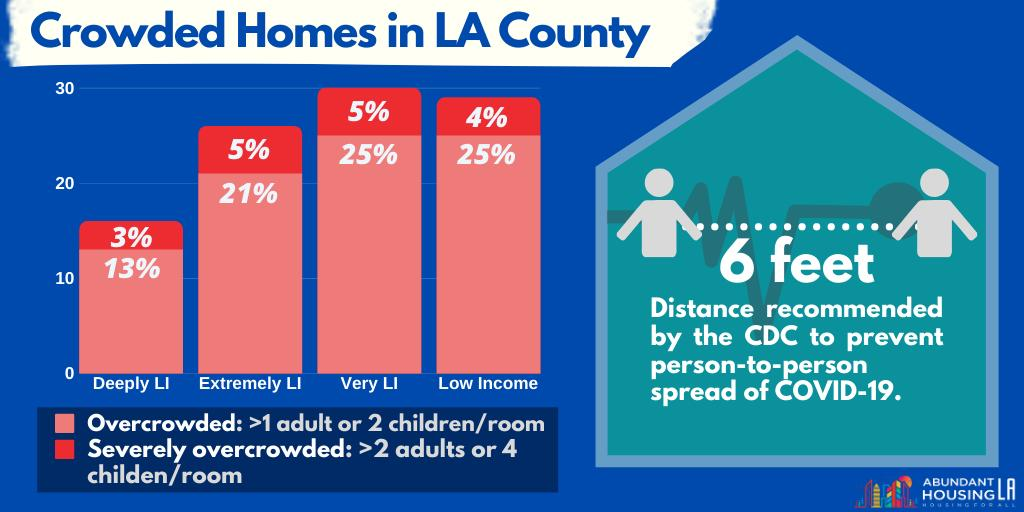List a handful of essential elements in this visual. According to a recent study, 21% of overcrowded households in LA county are earning an extremely low income. According to a recent study, 13% of overcrowded households in LA county belong to the deeply low income group. In Los Angeles County, only 4% of severely overcrowded households are earning low income, indicating that a significant majority of households struggling with overcrowding are not able to afford adequate housing. According to recent data, a small percentage of severely overcrowded households in LA county are earning an extremely low income, with the exact percentage being 5%. In Los Angeles County, 25% of overcrowded households are earning a very low income. 